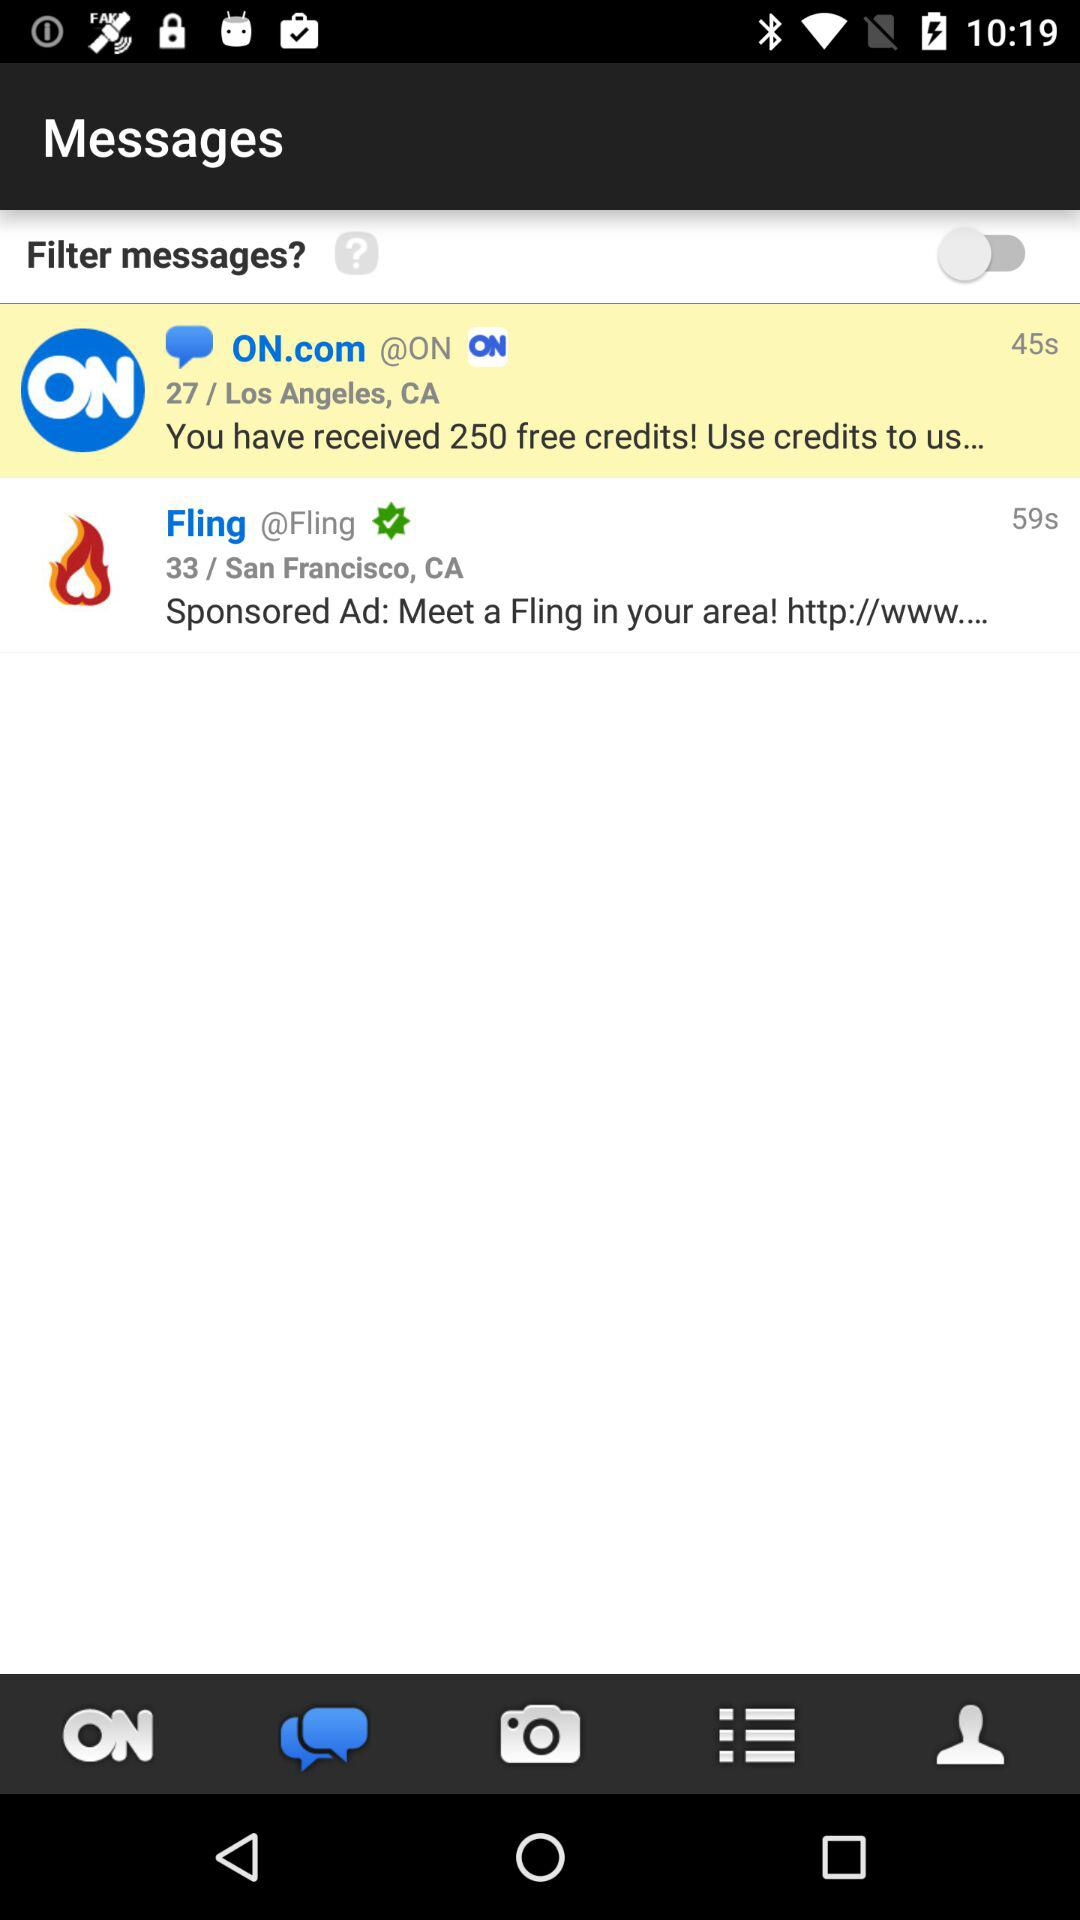How many messages are unread?
Answer the question using a single word or phrase. 2 